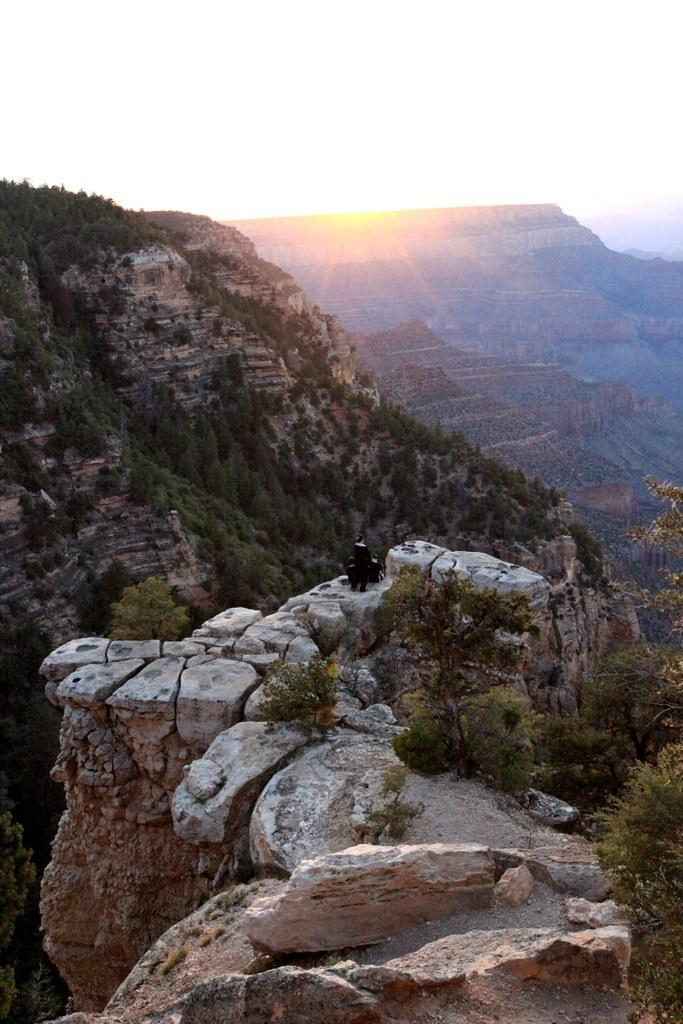What is the person in the image standing on? The person is standing on a rock. Where is the rock located? The rock is on a hill. What can be seen on the hill besides the rock? There are trees on the hill. What is visible in the background of the image? There are hills with trees in the background. What is visible at the top of the image? The sky is visible at the top of the image. What celestial body can be seen in the sky? The sun is present in the sky. What type of stamp can be seen on the person's forehead in the image? There is no stamp present on the person's forehead in the image. 